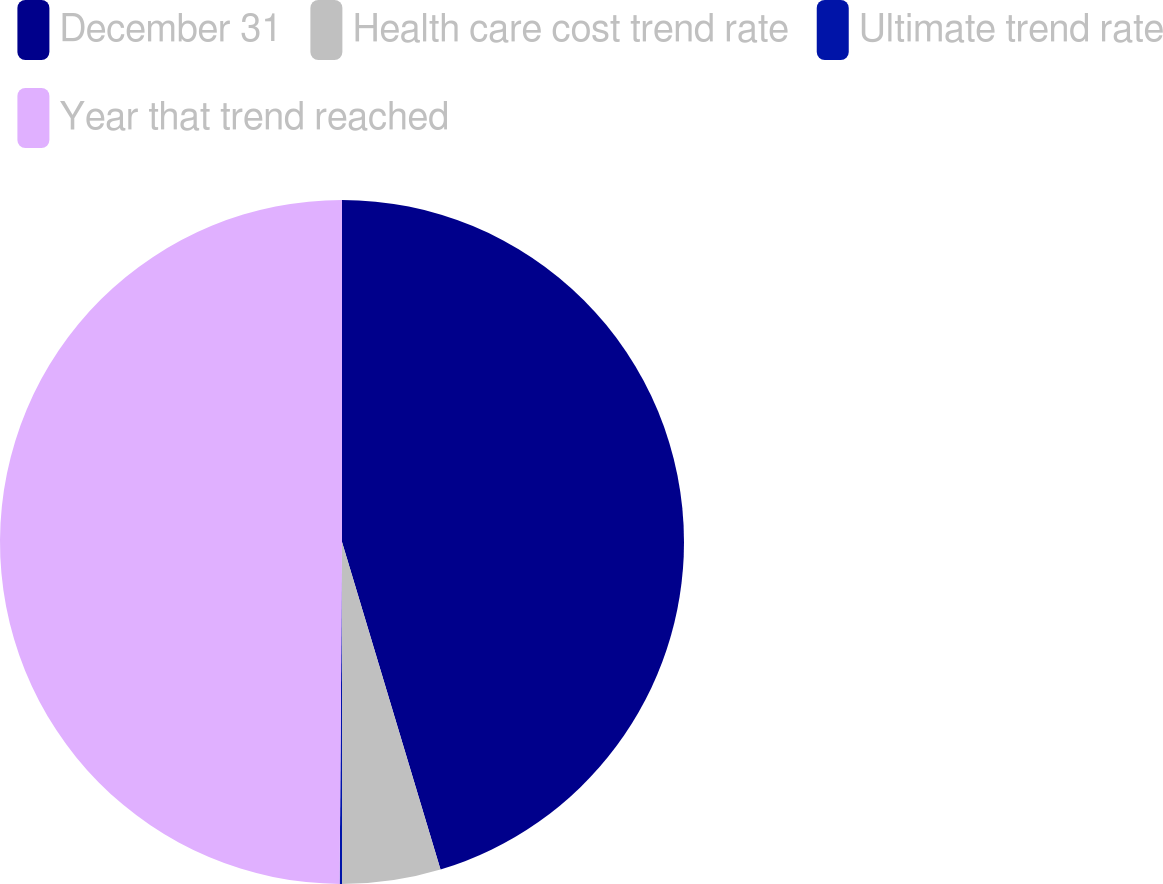<chart> <loc_0><loc_0><loc_500><loc_500><pie_chart><fcel>December 31<fcel>Health care cost trend rate<fcel>Ultimate trend rate<fcel>Year that trend reached<nl><fcel>45.35%<fcel>4.65%<fcel>0.11%<fcel>49.89%<nl></chart> 